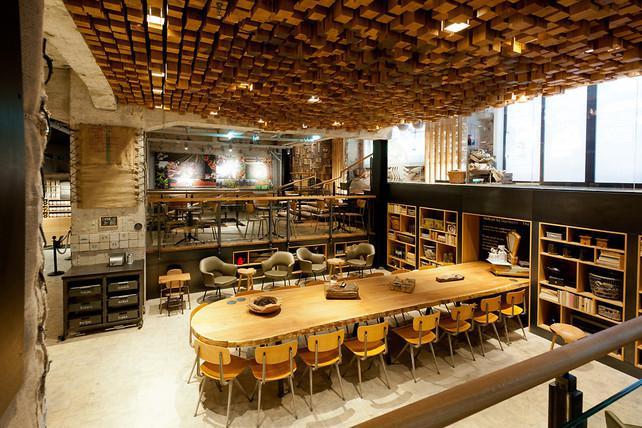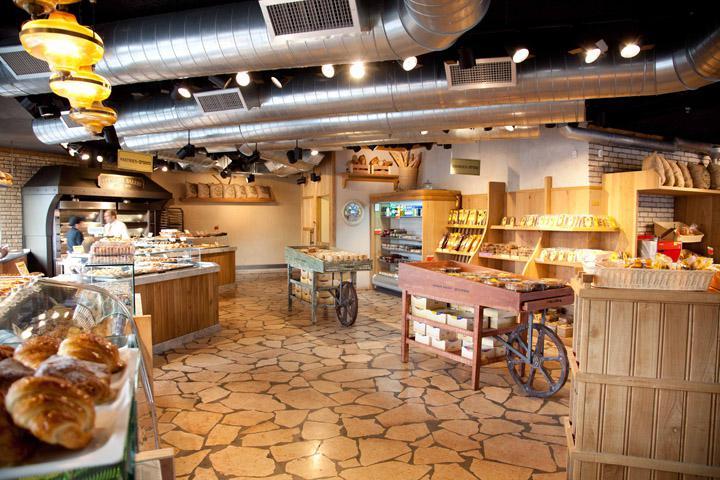The first image is the image on the left, the second image is the image on the right. Analyze the images presented: Is the assertion "Wooden tables and chairs for patrons to sit and eat are shown in one image." valid? Answer yes or no. Yes. The first image is the image on the left, the second image is the image on the right. Analyze the images presented: Is the assertion "One of the places has a wooden floor." valid? Answer yes or no. No. 